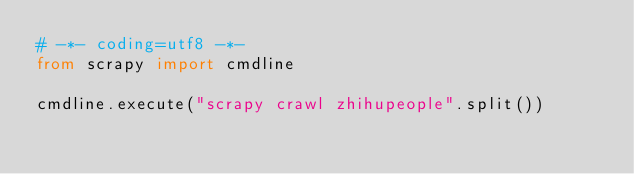<code> <loc_0><loc_0><loc_500><loc_500><_Python_># -*- coding=utf8 -*-
from scrapy import cmdline

cmdline.execute("scrapy crawl zhihupeople".split())
</code> 